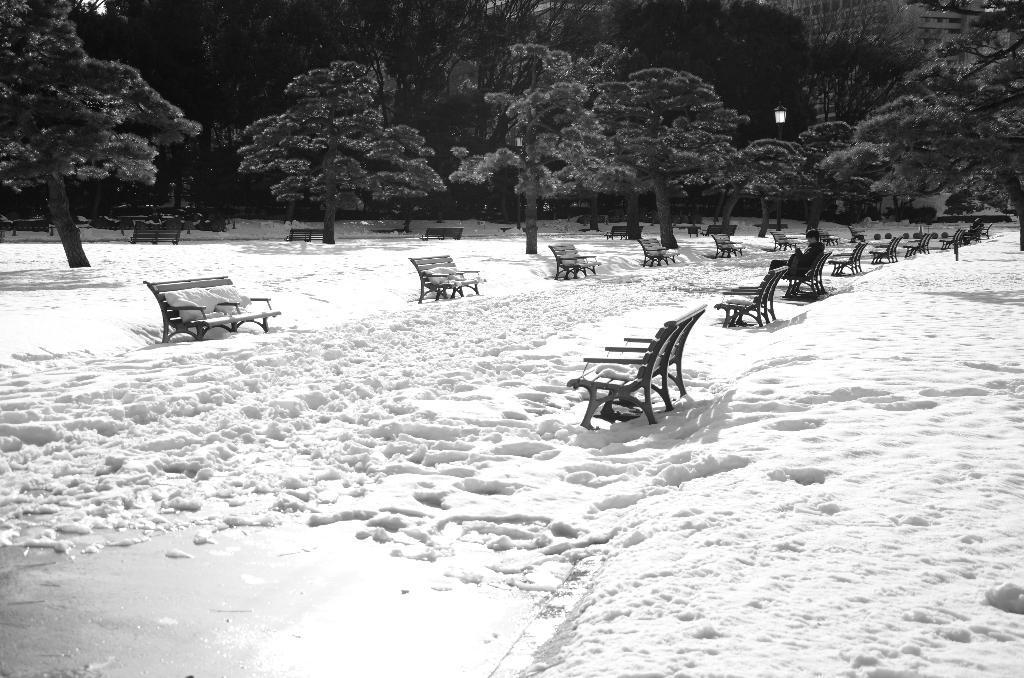Describe this image in one or two sentences. This is a black and white picture. Here we can see trees, benches, and a light. This is snow. In the background we can see a building. 